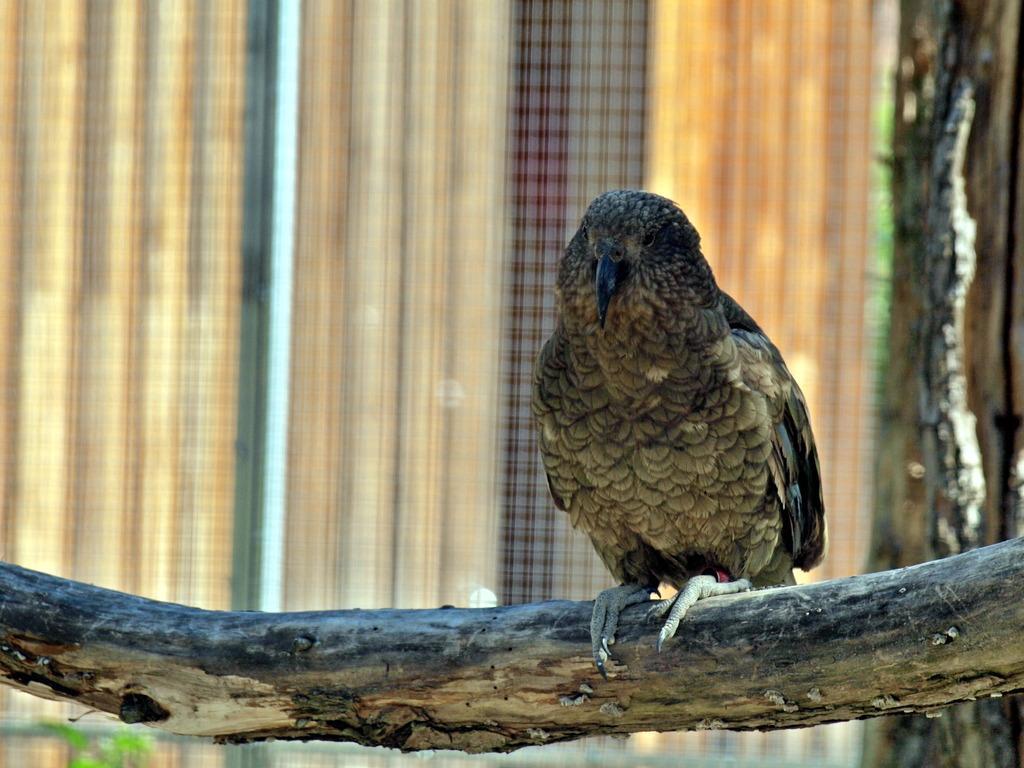Could you give a brief overview of what you see in this image? In this picture there is a Cooper's hawk standing on a wooden stick and there are some other objects in the background. 